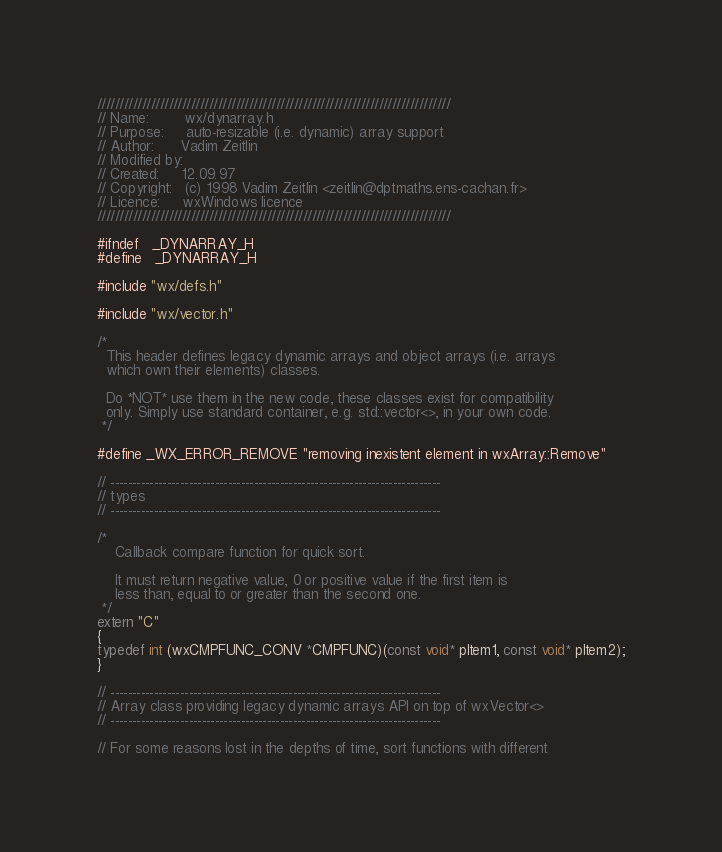<code> <loc_0><loc_0><loc_500><loc_500><_C_>///////////////////////////////////////////////////////////////////////////////
// Name:        wx/dynarray.h
// Purpose:     auto-resizable (i.e. dynamic) array support
// Author:      Vadim Zeitlin
// Modified by:
// Created:     12.09.97
// Copyright:   (c) 1998 Vadim Zeitlin <zeitlin@dptmaths.ens-cachan.fr>
// Licence:     wxWindows licence
///////////////////////////////////////////////////////////////////////////////

#ifndef   _DYNARRAY_H
#define   _DYNARRAY_H

#include "wx/defs.h"

#include "wx/vector.h"

/*
  This header defines legacy dynamic arrays and object arrays (i.e. arrays
  which own their elements) classes.

  Do *NOT* use them in the new code, these classes exist for compatibility
  only. Simply use standard container, e.g. std::vector<>, in your own code.
 */

#define _WX_ERROR_REMOVE "removing inexistent element in wxArray::Remove"

// ----------------------------------------------------------------------------
// types
// ----------------------------------------------------------------------------

/*
    Callback compare function for quick sort.

    It must return negative value, 0 or positive value if the first item is
    less than, equal to or greater than the second one.
 */
extern "C"
{
typedef int (wxCMPFUNC_CONV *CMPFUNC)(const void* pItem1, const void* pItem2);
}

// ----------------------------------------------------------------------------
// Array class providing legacy dynamic arrays API on top of wxVector<>
// ----------------------------------------------------------------------------

// For some reasons lost in the depths of time, sort functions with different</code> 